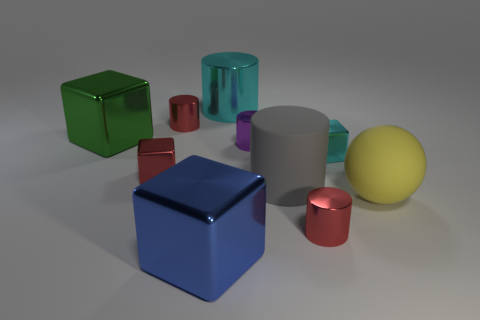What number of other objects are there of the same size as the yellow matte sphere?
Ensure brevity in your answer.  4. There is a big gray rubber thing; does it have the same shape as the large shiny thing that is in front of the big yellow matte object?
Make the answer very short. No. How many rubber things are small yellow things or small cubes?
Make the answer very short. 0. Is there a big shiny object of the same color as the matte ball?
Keep it short and to the point. No. Are any purple things visible?
Make the answer very short. Yes. Does the yellow object have the same shape as the big cyan thing?
Offer a very short reply. No. What number of tiny objects are either rubber cylinders or purple cylinders?
Keep it short and to the point. 1. What is the color of the matte cylinder?
Offer a terse response. Gray. What shape is the cyan thing to the right of the small metal object in front of the large yellow matte sphere?
Keep it short and to the point. Cube. Are there any large balls that have the same material as the large yellow thing?
Offer a very short reply. No. 